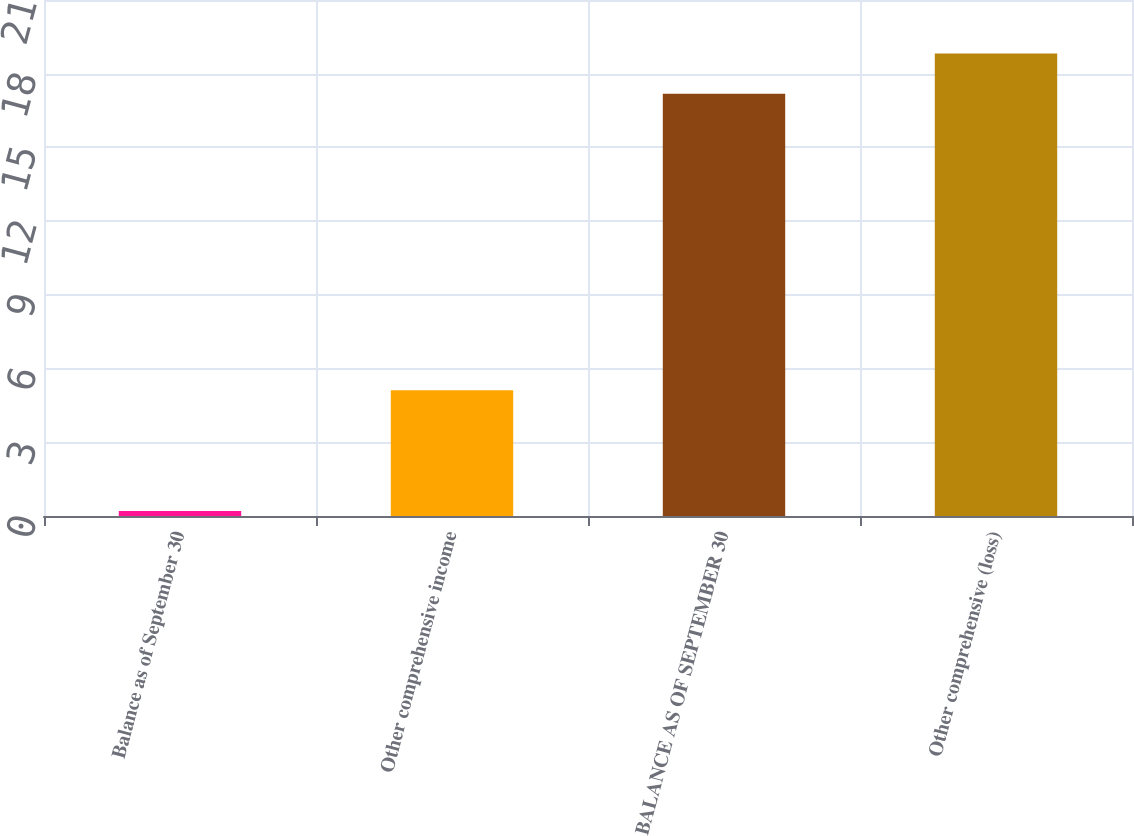Convert chart. <chart><loc_0><loc_0><loc_500><loc_500><bar_chart><fcel>Balance as of September 30<fcel>Other comprehensive income<fcel>BALANCE AS OF SEPTEMBER 30<fcel>Other comprehensive (loss)<nl><fcel>0.2<fcel>5.12<fcel>17.18<fcel>18.82<nl></chart> 